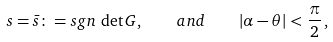Convert formula to latex. <formula><loc_0><loc_0><loc_500><loc_500>s = \bar { s } \colon = { s g n } \, \det G , \quad a n d \quad | \alpha - \theta | < \frac { \pi } { 2 } \, ,</formula> 